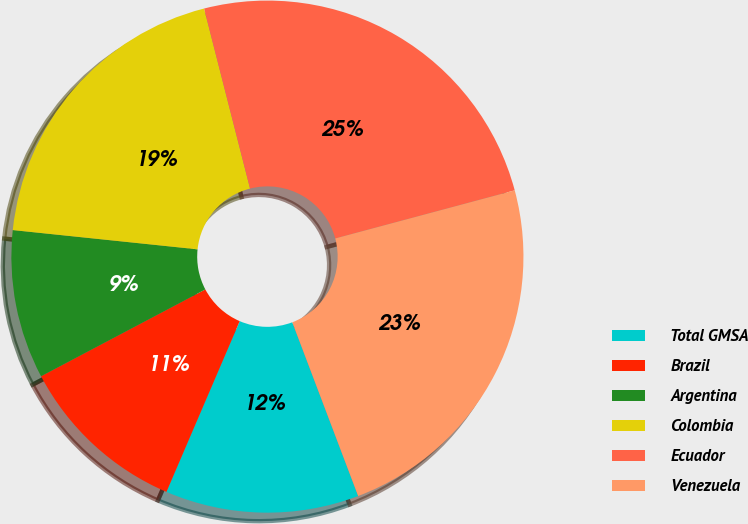Convert chart. <chart><loc_0><loc_0><loc_500><loc_500><pie_chart><fcel>Total GMSA<fcel>Brazil<fcel>Argentina<fcel>Colombia<fcel>Ecuador<fcel>Venezuela<nl><fcel>12.22%<fcel>10.81%<fcel>9.39%<fcel>19.37%<fcel>24.81%<fcel>23.4%<nl></chart> 